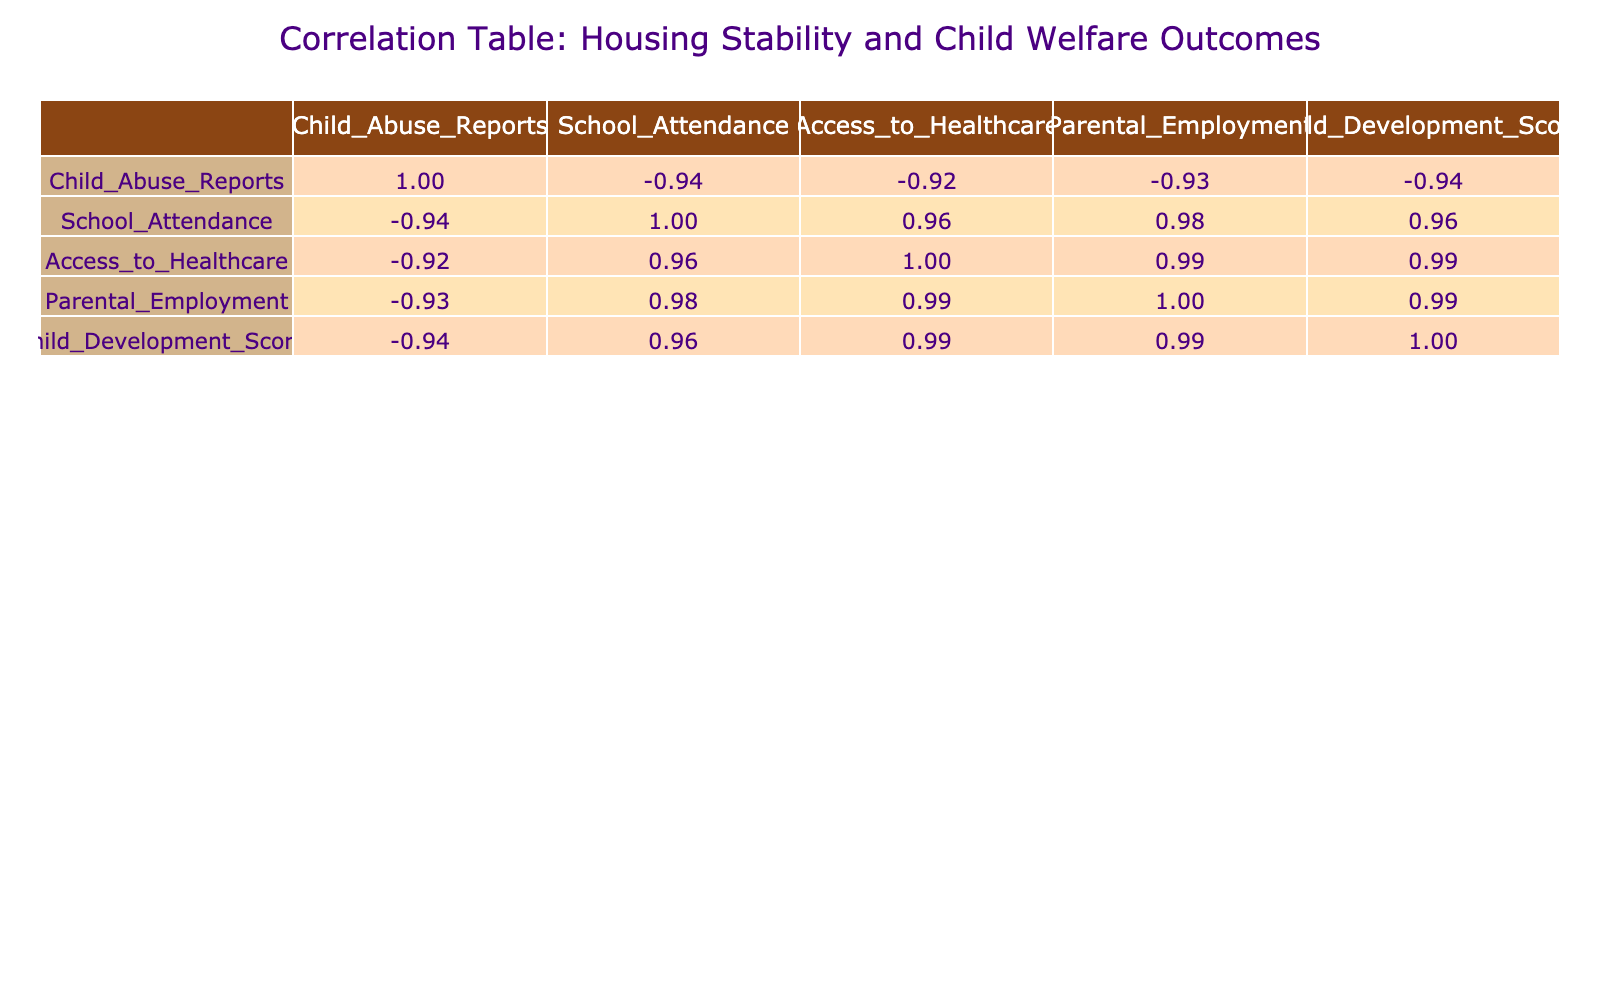What is the correlation coefficient between Housing Stability and Child Abuse Reports? The correlation coefficient can be found in the table under the respective columns. For Housing Stability and Child Abuse Reports, the value is -0.92, indicating a strong negative correlation.
Answer: -0.92 What is the average Child Development Score for families with Moderate Housing Stability? For Moderate Housing Stability, the Child Development Scores are 75, 70, 68, and 72. Summing these gives 75 + 70 + 68 + 72 = 285. There are 4 data points, so the average is 285 / 4 = 71.25.
Answer: 71.25 Is there a positive correlation between Access to Healthcare and Housing Stability? By observing the table, the correlation coefficient between Housing Stability and Access to Healthcare is 0.94, indicating a strong positive correlation. So, yes, there is a positive correlation.
Answer: Yes What is the difference in average School Attendance between families with High and Low Housing Stability? For High Housing Stability, School Attendance values are 95, 90, 92, 96. The average is (95 + 90 + 92 + 96) / 4 = 93.25. For Low, the values are 70, 75, 68, 65. The average is (70 + 75 + 68 + 65) / 4 = 69.3. Therefore, the difference is 93.25 - 69.3 = 23.95.
Answer: 23.95 Do all child welfare outcomes improve as Housing Stability increases? By examining the correlation values, it shows that Child Abuse Reports increase (negative correlation), while School Attendance, Access to Healthcare, and Child Development Scores all show positive correlations. Thus, they do not all improve.
Answer: No 